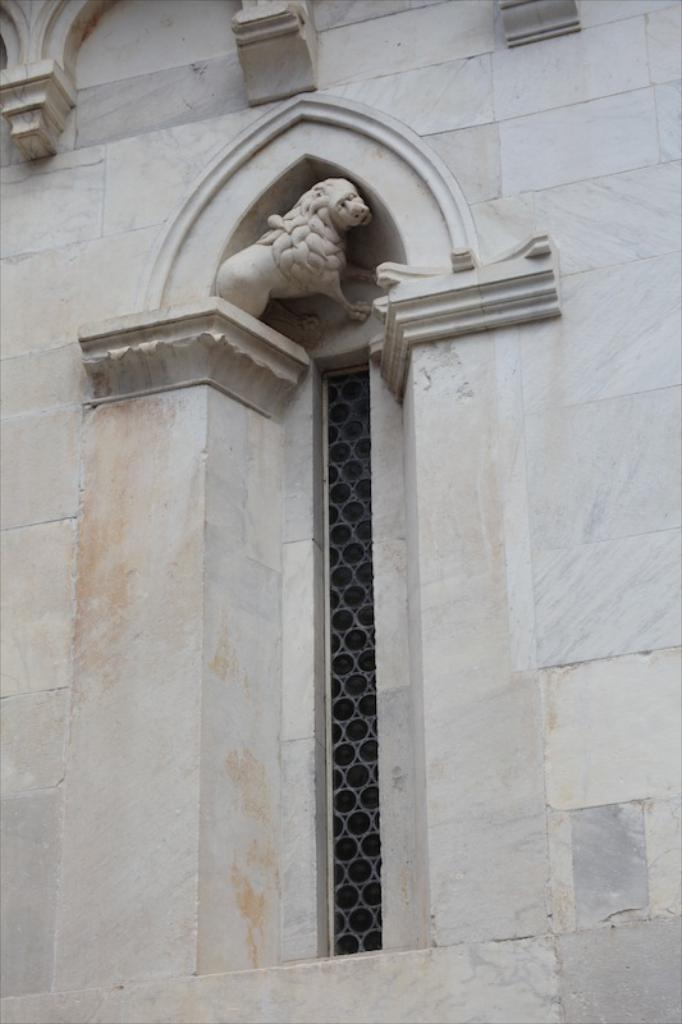What type of structure can be seen in the image? There is a wall in the image. Are there any openings in the wall? Yes, there is a window in the wall. What other structures are visible in the image? There is a fence in the image. What decorative element is present on the wall? There is a sculpture on the wall. How does the minister care for the volcano in the image? There is no minister or volcano present in the image. 